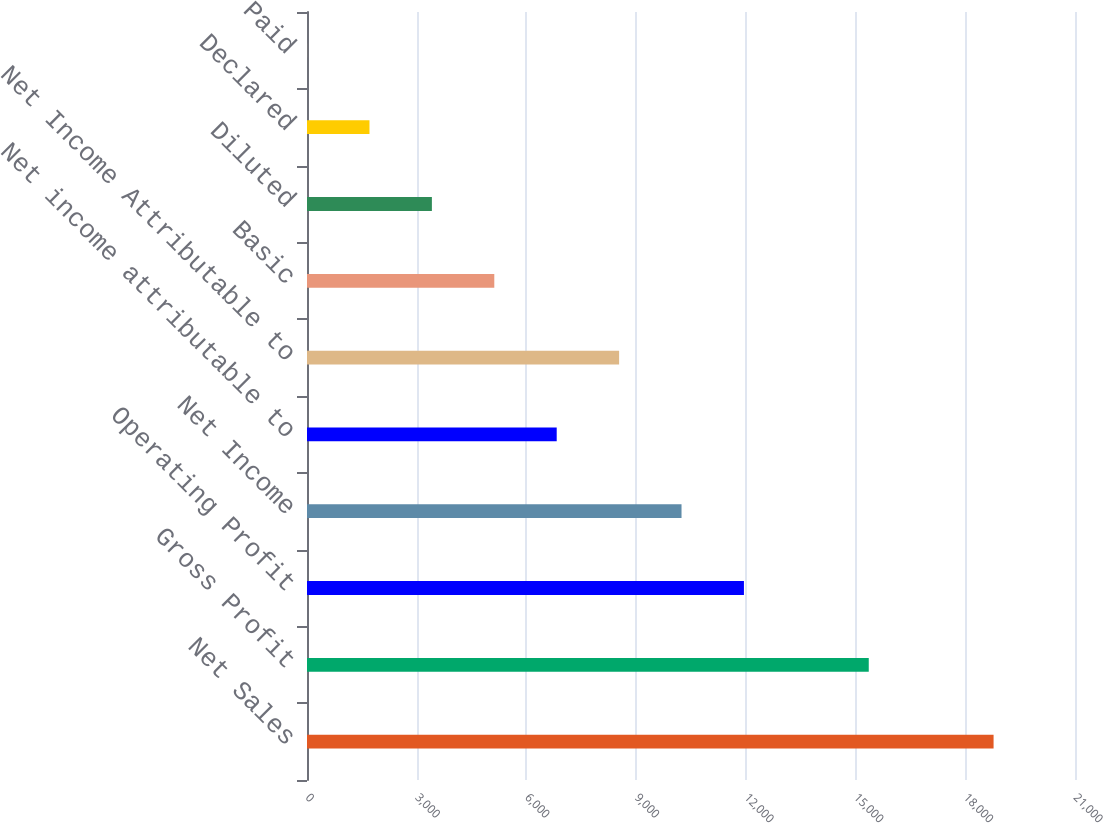Convert chart to OTSL. <chart><loc_0><loc_0><loc_500><loc_500><bar_chart><fcel>Net Sales<fcel>Gross Profit<fcel>Operating Profit<fcel>Net Income<fcel>Net income attributable to<fcel>Net Income Attributable to<fcel>Basic<fcel>Diluted<fcel>Declared<fcel>Paid<nl><fcel>18773.5<fcel>15360.5<fcel>11947.5<fcel>10241<fcel>6827.96<fcel>8534.47<fcel>5121.45<fcel>3414.94<fcel>1708.43<fcel>1.92<nl></chart> 